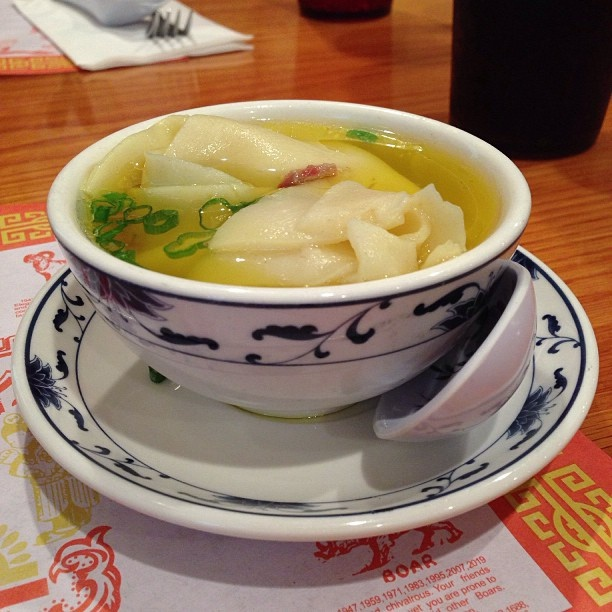Describe the objects in this image and their specific colors. I can see dining table in lightgray, brown, black, darkgray, and gray tones, bowl in lightgray, gray, and tan tones, bowl in lightgray, darkgray, gray, and black tones, and fork in lightgray, gray, darkgray, and black tones in this image. 